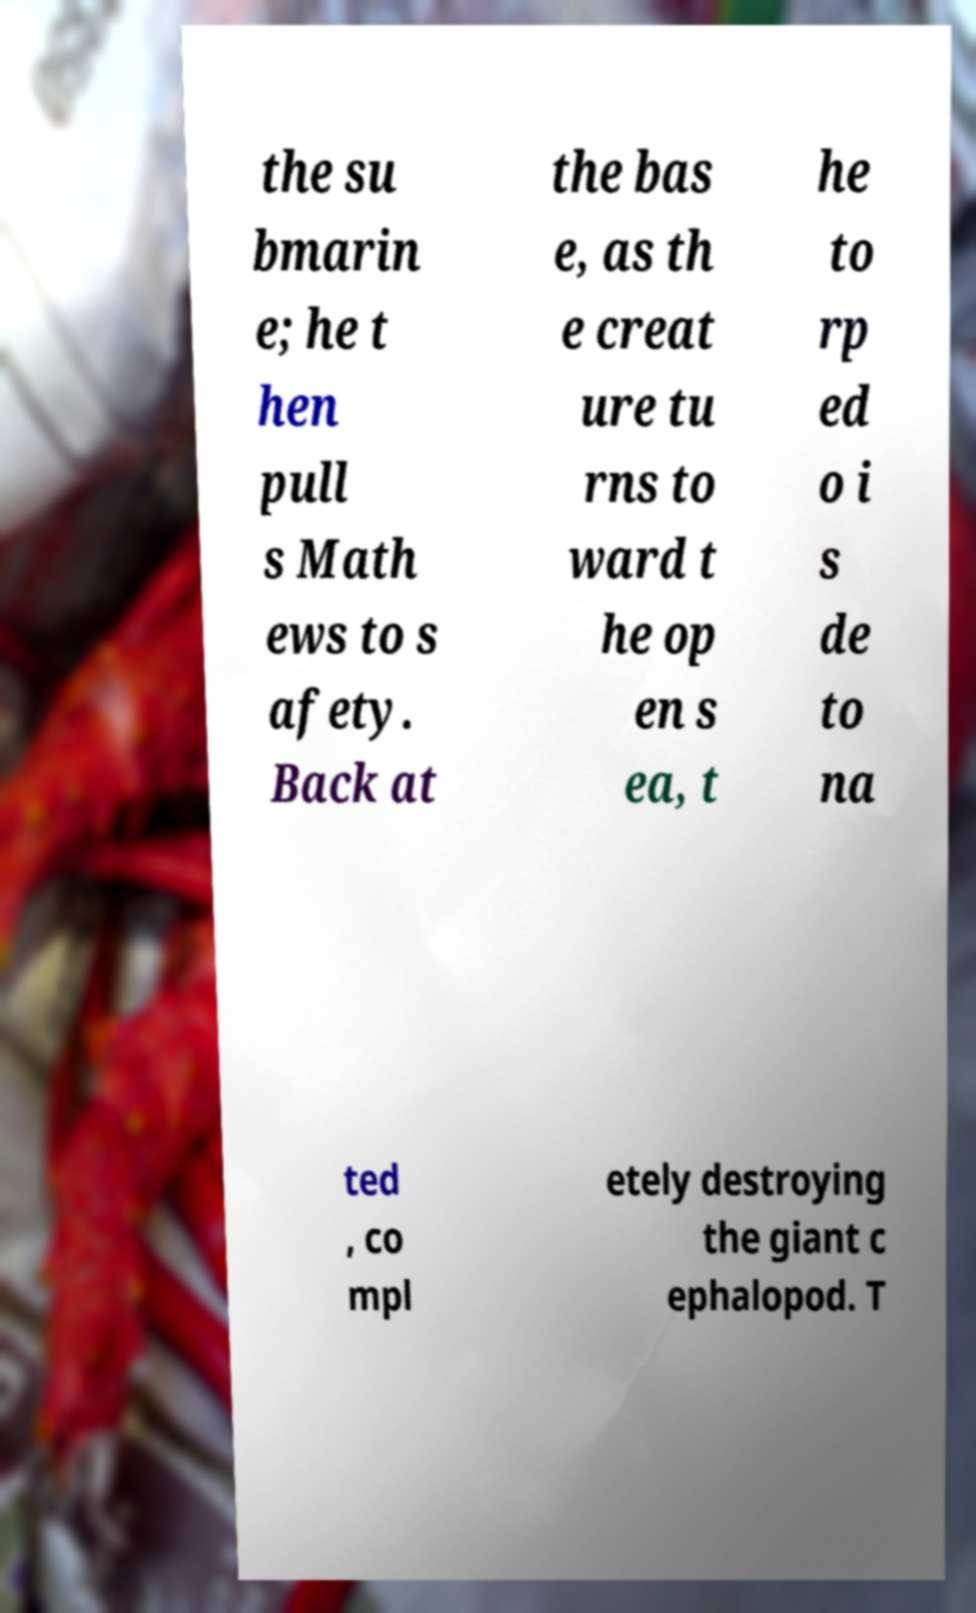What messages or text are displayed in this image? I need them in a readable, typed format. the su bmarin e; he t hen pull s Math ews to s afety. Back at the bas e, as th e creat ure tu rns to ward t he op en s ea, t he to rp ed o i s de to na ted , co mpl etely destroying the giant c ephalopod. T 